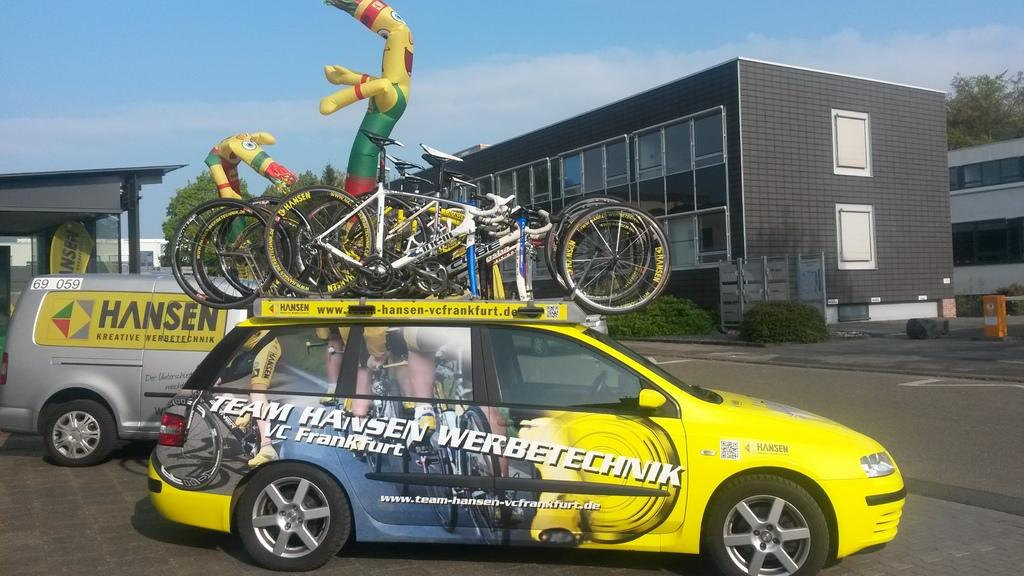Provide a one-sentence caption for the provided image. A yellow car has several bikes on top, belonging to Team Hansen Werbetechnik. 